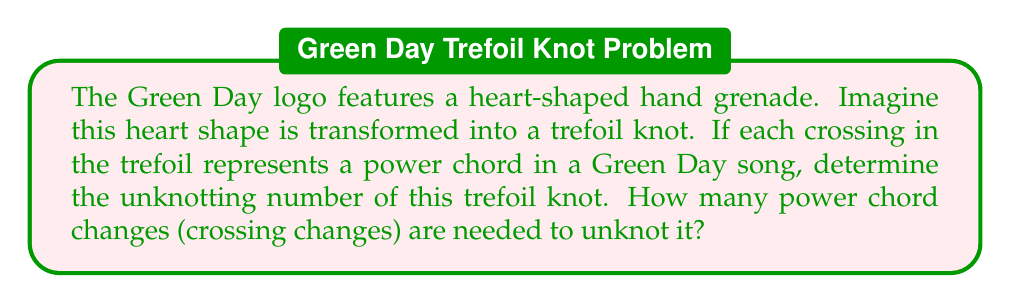What is the answer to this math problem? To solve this problem, we need to understand the concept of unknotting number and apply it to the trefoil knot:

1. The trefoil knot is the simplest non-trivial knot, represented by the following diagram:

[asy]
import geometry;

path p = (0,0){dir(60)}..{dir(-60)}(1,0){dir(120)}..{dir(0)}(2,0){dir(-120)}..{dir(180)}cycle;
draw(p,linewidth(1));
draw((0.9,-0.2)--(1.1,0.2),linewidth(0.7));
draw((1.9,-0.2)--(2.1,0.2),linewidth(0.7));
draw((-0.1,-0.2)--(0.1,0.2),linewidth(0.7));
[/asy]

2. The unknotting number of a knot is the minimum number of crossing changes required to transform the knot into the unknot (a simple closed loop).

3. For the trefoil knot, we can prove that the unknotting number is 1:

   a. Changing any one of the three crossings will result in the unknot.
   b. It's impossible to unknot the trefoil with zero crossing changes, as it's a non-trivial knot.

4. Mathematically, we can express the unknotting number $u(K)$ for a trefoil knot $K$ as:

   $$u(K) = 1$$

5. In the context of Green Day's music, each crossing change represents a power chord change. Therefore, we need only one power chord change to "unknot" our Green Day-inspired trefoil knot.
Answer: 1 